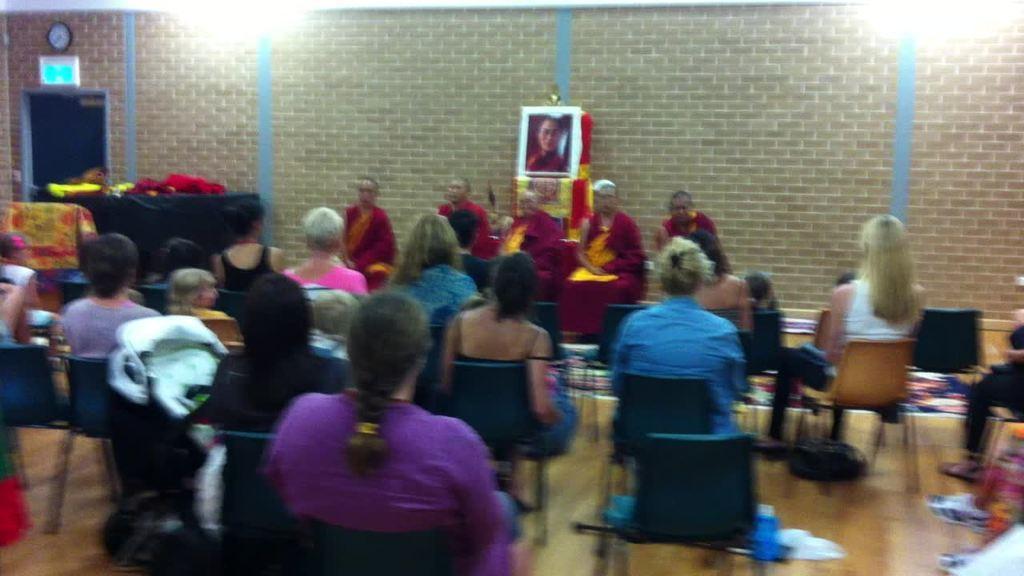How would you summarize this image in a sentence or two? In this image we can see few people sitting on the cars, there are few objects on the floor and few objects on the table, there is a photo frame, a clock and a board on the wall. 